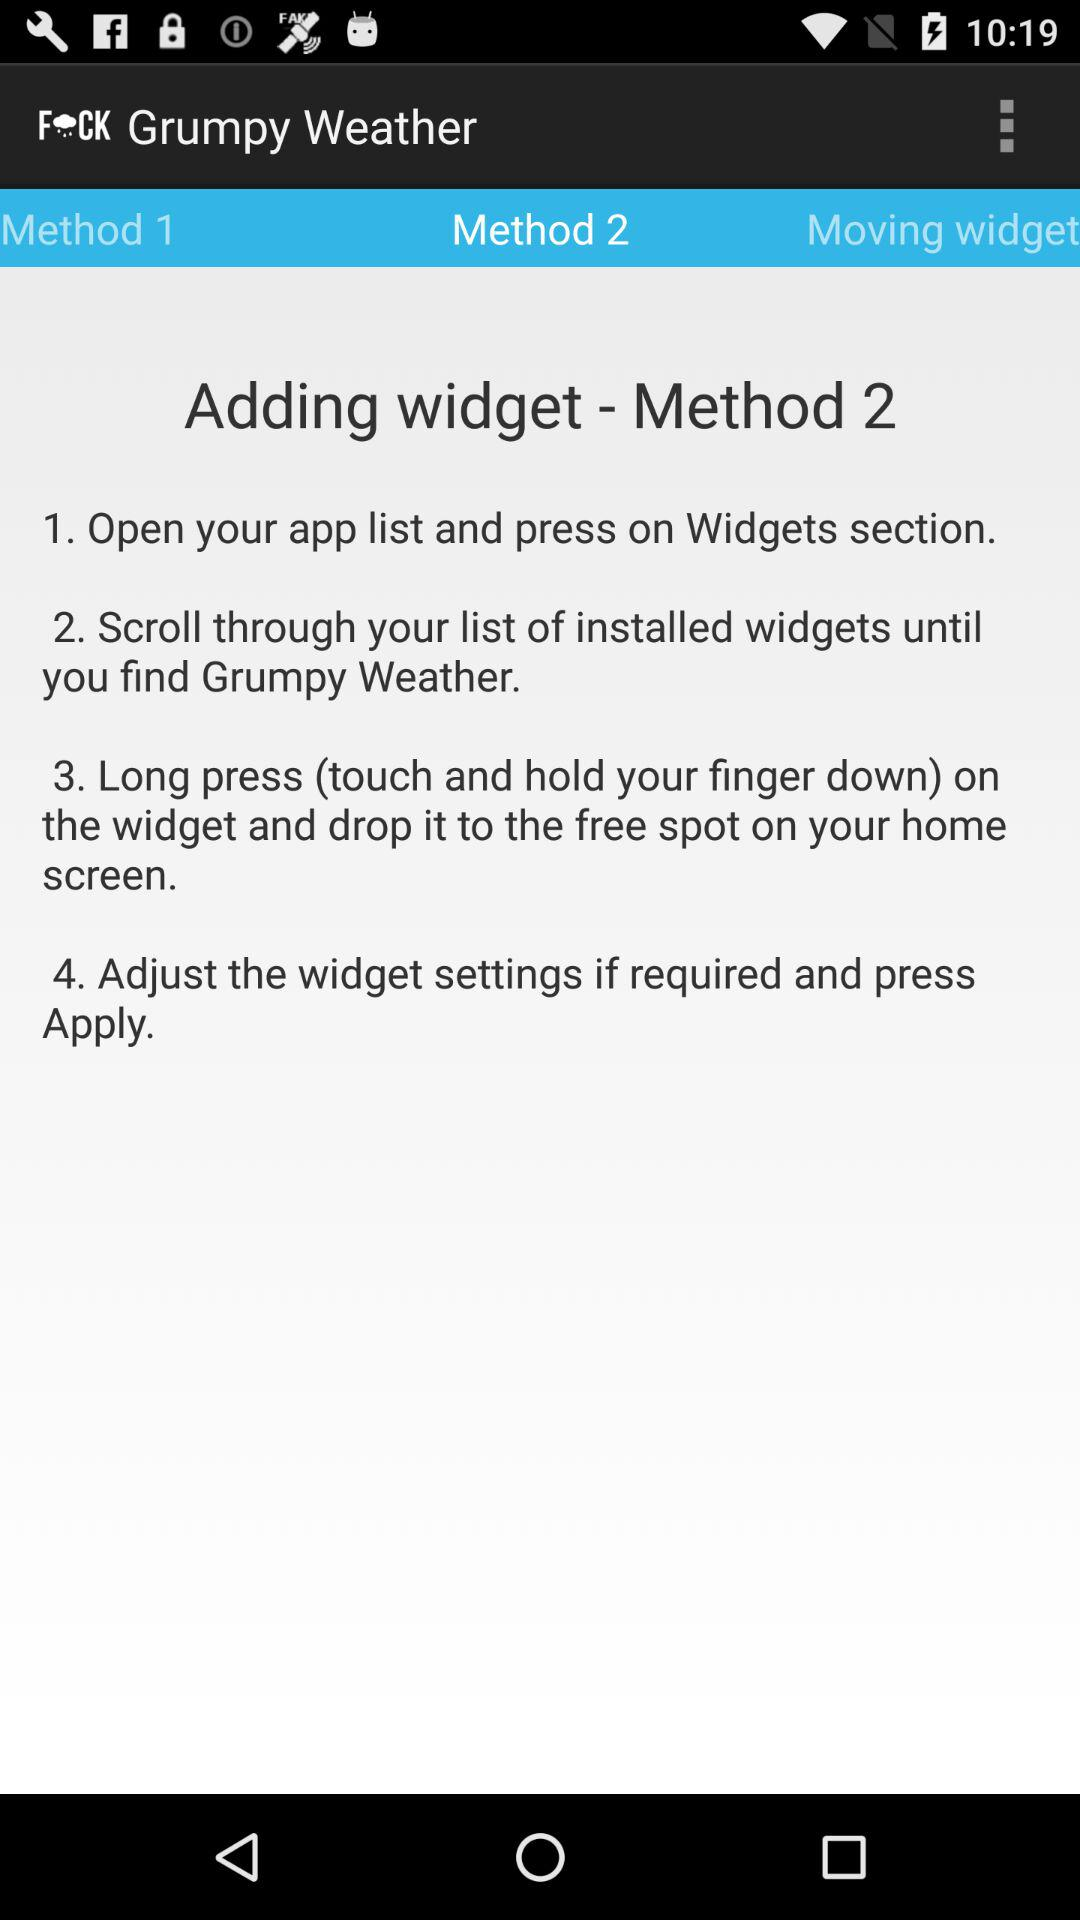Which tab has been selected? The selected tab is "Method 2". 